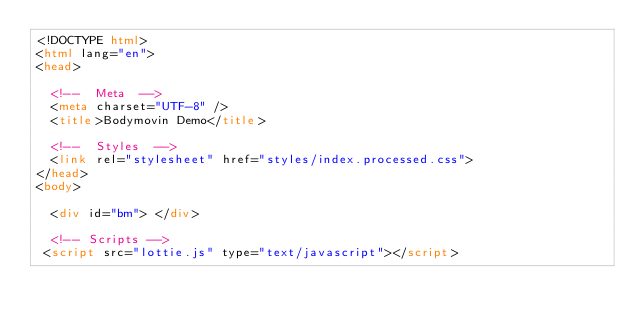<code> <loc_0><loc_0><loc_500><loc_500><_HTML_><!DOCTYPE html>
<html lang="en">
<head>
  
  <!--  Meta  -->
  <meta charset="UTF-8" />
  <title>Bodymovin Demo</title>
  
  <!--  Styles  -->
  <link rel="stylesheet" href="styles/index.processed.css">
</head>
<body>
  
  <div id="bm"> </div>
  
  <!-- Scripts -->
 <script src="lottie.js" type="text/javascript"></script></code> 